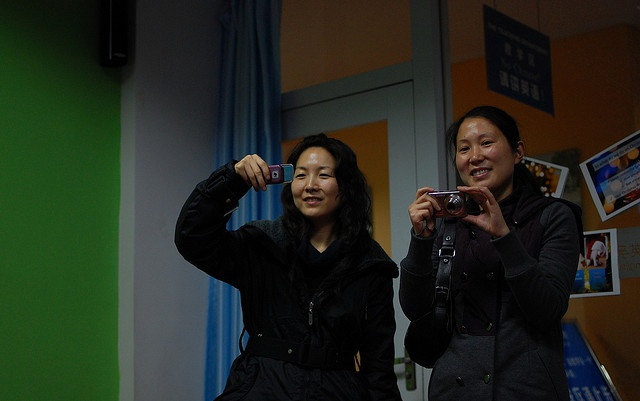Describe the objects in this image and their specific colors. I can see people in black, maroon, and gray tones, people in black, gray, and maroon tones, handbag in black, gray, and purple tones, and cell phone in black, blue, gray, and darkblue tones in this image. 